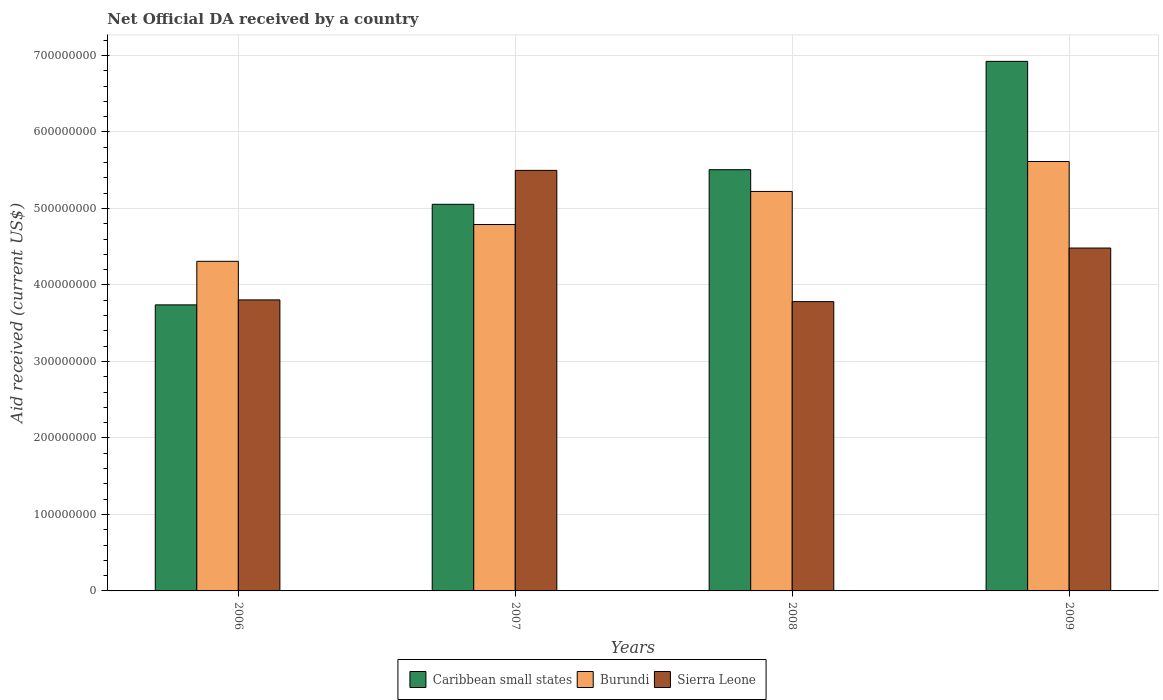Are the number of bars on each tick of the X-axis equal?
Your answer should be compact. Yes. How many bars are there on the 1st tick from the right?
Your answer should be very brief. 3. What is the label of the 3rd group of bars from the left?
Your response must be concise. 2008. In how many cases, is the number of bars for a given year not equal to the number of legend labels?
Provide a short and direct response. 0. What is the net official development assistance aid received in Burundi in 2008?
Ensure brevity in your answer.  5.22e+08. Across all years, what is the maximum net official development assistance aid received in Sierra Leone?
Keep it short and to the point. 5.50e+08. Across all years, what is the minimum net official development assistance aid received in Caribbean small states?
Your answer should be compact. 3.74e+08. In which year was the net official development assistance aid received in Sierra Leone maximum?
Your response must be concise. 2007. In which year was the net official development assistance aid received in Caribbean small states minimum?
Keep it short and to the point. 2006. What is the total net official development assistance aid received in Sierra Leone in the graph?
Provide a succinct answer. 1.76e+09. What is the difference between the net official development assistance aid received in Burundi in 2006 and that in 2008?
Ensure brevity in your answer.  -9.14e+07. What is the difference between the net official development assistance aid received in Sierra Leone in 2007 and the net official development assistance aid received in Caribbean small states in 2009?
Offer a very short reply. -1.43e+08. What is the average net official development assistance aid received in Caribbean small states per year?
Your answer should be compact. 5.31e+08. In the year 2006, what is the difference between the net official development assistance aid received in Burundi and net official development assistance aid received in Caribbean small states?
Your response must be concise. 5.69e+07. What is the ratio of the net official development assistance aid received in Caribbean small states in 2007 to that in 2009?
Offer a terse response. 0.73. Is the net official development assistance aid received in Sierra Leone in 2006 less than that in 2009?
Your response must be concise. Yes. Is the difference between the net official development assistance aid received in Burundi in 2006 and 2008 greater than the difference between the net official development assistance aid received in Caribbean small states in 2006 and 2008?
Your answer should be compact. Yes. What is the difference between the highest and the second highest net official development assistance aid received in Burundi?
Your answer should be very brief. 3.91e+07. What is the difference between the highest and the lowest net official development assistance aid received in Sierra Leone?
Give a very brief answer. 1.72e+08. What does the 3rd bar from the left in 2009 represents?
Make the answer very short. Sierra Leone. What does the 3rd bar from the right in 2007 represents?
Your response must be concise. Caribbean small states. Is it the case that in every year, the sum of the net official development assistance aid received in Burundi and net official development assistance aid received in Sierra Leone is greater than the net official development assistance aid received in Caribbean small states?
Give a very brief answer. Yes. What is the difference between two consecutive major ticks on the Y-axis?
Make the answer very short. 1.00e+08. Where does the legend appear in the graph?
Your answer should be very brief. Bottom center. How many legend labels are there?
Make the answer very short. 3. How are the legend labels stacked?
Your answer should be compact. Horizontal. What is the title of the graph?
Offer a very short reply. Net Official DA received by a country. Does "Fragile and conflict affected situations" appear as one of the legend labels in the graph?
Make the answer very short. No. What is the label or title of the Y-axis?
Your response must be concise. Aid received (current US$). What is the Aid received (current US$) in Caribbean small states in 2006?
Your answer should be compact. 3.74e+08. What is the Aid received (current US$) in Burundi in 2006?
Provide a succinct answer. 4.31e+08. What is the Aid received (current US$) of Sierra Leone in 2006?
Offer a very short reply. 3.80e+08. What is the Aid received (current US$) of Caribbean small states in 2007?
Your answer should be compact. 5.05e+08. What is the Aid received (current US$) of Burundi in 2007?
Your answer should be compact. 4.79e+08. What is the Aid received (current US$) of Sierra Leone in 2007?
Offer a terse response. 5.50e+08. What is the Aid received (current US$) in Caribbean small states in 2008?
Offer a terse response. 5.51e+08. What is the Aid received (current US$) of Burundi in 2008?
Provide a short and direct response. 5.22e+08. What is the Aid received (current US$) of Sierra Leone in 2008?
Keep it short and to the point. 3.78e+08. What is the Aid received (current US$) of Caribbean small states in 2009?
Give a very brief answer. 6.92e+08. What is the Aid received (current US$) in Burundi in 2009?
Provide a succinct answer. 5.61e+08. What is the Aid received (current US$) in Sierra Leone in 2009?
Your response must be concise. 4.48e+08. Across all years, what is the maximum Aid received (current US$) of Caribbean small states?
Provide a succinct answer. 6.92e+08. Across all years, what is the maximum Aid received (current US$) in Burundi?
Give a very brief answer. 5.61e+08. Across all years, what is the maximum Aid received (current US$) in Sierra Leone?
Ensure brevity in your answer.  5.50e+08. Across all years, what is the minimum Aid received (current US$) in Caribbean small states?
Keep it short and to the point. 3.74e+08. Across all years, what is the minimum Aid received (current US$) of Burundi?
Provide a succinct answer. 4.31e+08. Across all years, what is the minimum Aid received (current US$) in Sierra Leone?
Your answer should be very brief. 3.78e+08. What is the total Aid received (current US$) in Caribbean small states in the graph?
Your response must be concise. 2.12e+09. What is the total Aid received (current US$) of Burundi in the graph?
Provide a short and direct response. 1.99e+09. What is the total Aid received (current US$) in Sierra Leone in the graph?
Your answer should be very brief. 1.76e+09. What is the difference between the Aid received (current US$) in Caribbean small states in 2006 and that in 2007?
Provide a succinct answer. -1.31e+08. What is the difference between the Aid received (current US$) of Burundi in 2006 and that in 2007?
Make the answer very short. -4.81e+07. What is the difference between the Aid received (current US$) of Sierra Leone in 2006 and that in 2007?
Offer a very short reply. -1.69e+08. What is the difference between the Aid received (current US$) in Caribbean small states in 2006 and that in 2008?
Your answer should be very brief. -1.77e+08. What is the difference between the Aid received (current US$) of Burundi in 2006 and that in 2008?
Offer a terse response. -9.14e+07. What is the difference between the Aid received (current US$) of Sierra Leone in 2006 and that in 2008?
Keep it short and to the point. 2.26e+06. What is the difference between the Aid received (current US$) of Caribbean small states in 2006 and that in 2009?
Keep it short and to the point. -3.18e+08. What is the difference between the Aid received (current US$) of Burundi in 2006 and that in 2009?
Your answer should be very brief. -1.30e+08. What is the difference between the Aid received (current US$) in Sierra Leone in 2006 and that in 2009?
Offer a terse response. -6.78e+07. What is the difference between the Aid received (current US$) of Caribbean small states in 2007 and that in 2008?
Provide a short and direct response. -4.52e+07. What is the difference between the Aid received (current US$) in Burundi in 2007 and that in 2008?
Your response must be concise. -4.32e+07. What is the difference between the Aid received (current US$) of Sierra Leone in 2007 and that in 2008?
Offer a terse response. 1.72e+08. What is the difference between the Aid received (current US$) in Caribbean small states in 2007 and that in 2009?
Ensure brevity in your answer.  -1.87e+08. What is the difference between the Aid received (current US$) in Burundi in 2007 and that in 2009?
Offer a very short reply. -8.24e+07. What is the difference between the Aid received (current US$) of Sierra Leone in 2007 and that in 2009?
Offer a terse response. 1.02e+08. What is the difference between the Aid received (current US$) in Caribbean small states in 2008 and that in 2009?
Give a very brief answer. -1.42e+08. What is the difference between the Aid received (current US$) of Burundi in 2008 and that in 2009?
Offer a very short reply. -3.91e+07. What is the difference between the Aid received (current US$) in Sierra Leone in 2008 and that in 2009?
Provide a succinct answer. -7.00e+07. What is the difference between the Aid received (current US$) of Caribbean small states in 2006 and the Aid received (current US$) of Burundi in 2007?
Provide a succinct answer. -1.05e+08. What is the difference between the Aid received (current US$) in Caribbean small states in 2006 and the Aid received (current US$) in Sierra Leone in 2007?
Provide a succinct answer. -1.76e+08. What is the difference between the Aid received (current US$) of Burundi in 2006 and the Aid received (current US$) of Sierra Leone in 2007?
Provide a succinct answer. -1.19e+08. What is the difference between the Aid received (current US$) of Caribbean small states in 2006 and the Aid received (current US$) of Burundi in 2008?
Provide a succinct answer. -1.48e+08. What is the difference between the Aid received (current US$) in Caribbean small states in 2006 and the Aid received (current US$) in Sierra Leone in 2008?
Make the answer very short. -4.24e+06. What is the difference between the Aid received (current US$) of Burundi in 2006 and the Aid received (current US$) of Sierra Leone in 2008?
Keep it short and to the point. 5.27e+07. What is the difference between the Aid received (current US$) in Caribbean small states in 2006 and the Aid received (current US$) in Burundi in 2009?
Provide a succinct answer. -1.87e+08. What is the difference between the Aid received (current US$) in Caribbean small states in 2006 and the Aid received (current US$) in Sierra Leone in 2009?
Give a very brief answer. -7.43e+07. What is the difference between the Aid received (current US$) of Burundi in 2006 and the Aid received (current US$) of Sierra Leone in 2009?
Keep it short and to the point. -1.74e+07. What is the difference between the Aid received (current US$) of Caribbean small states in 2007 and the Aid received (current US$) of Burundi in 2008?
Provide a succinct answer. -1.68e+07. What is the difference between the Aid received (current US$) of Caribbean small states in 2007 and the Aid received (current US$) of Sierra Leone in 2008?
Ensure brevity in your answer.  1.27e+08. What is the difference between the Aid received (current US$) in Burundi in 2007 and the Aid received (current US$) in Sierra Leone in 2008?
Your answer should be compact. 1.01e+08. What is the difference between the Aid received (current US$) in Caribbean small states in 2007 and the Aid received (current US$) in Burundi in 2009?
Keep it short and to the point. -5.59e+07. What is the difference between the Aid received (current US$) in Caribbean small states in 2007 and the Aid received (current US$) in Sierra Leone in 2009?
Ensure brevity in your answer.  5.72e+07. What is the difference between the Aid received (current US$) in Burundi in 2007 and the Aid received (current US$) in Sierra Leone in 2009?
Make the answer very short. 3.07e+07. What is the difference between the Aid received (current US$) of Caribbean small states in 2008 and the Aid received (current US$) of Burundi in 2009?
Make the answer very short. -1.07e+07. What is the difference between the Aid received (current US$) in Caribbean small states in 2008 and the Aid received (current US$) in Sierra Leone in 2009?
Make the answer very short. 1.02e+08. What is the difference between the Aid received (current US$) of Burundi in 2008 and the Aid received (current US$) of Sierra Leone in 2009?
Your answer should be compact. 7.40e+07. What is the average Aid received (current US$) of Caribbean small states per year?
Your answer should be very brief. 5.31e+08. What is the average Aid received (current US$) of Burundi per year?
Provide a short and direct response. 4.98e+08. What is the average Aid received (current US$) in Sierra Leone per year?
Your answer should be very brief. 4.39e+08. In the year 2006, what is the difference between the Aid received (current US$) of Caribbean small states and Aid received (current US$) of Burundi?
Ensure brevity in your answer.  -5.69e+07. In the year 2006, what is the difference between the Aid received (current US$) of Caribbean small states and Aid received (current US$) of Sierra Leone?
Give a very brief answer. -6.50e+06. In the year 2006, what is the difference between the Aid received (current US$) in Burundi and Aid received (current US$) in Sierra Leone?
Your response must be concise. 5.04e+07. In the year 2007, what is the difference between the Aid received (current US$) of Caribbean small states and Aid received (current US$) of Burundi?
Offer a very short reply. 2.64e+07. In the year 2007, what is the difference between the Aid received (current US$) in Caribbean small states and Aid received (current US$) in Sierra Leone?
Provide a short and direct response. -4.43e+07. In the year 2007, what is the difference between the Aid received (current US$) in Burundi and Aid received (current US$) in Sierra Leone?
Offer a terse response. -7.08e+07. In the year 2008, what is the difference between the Aid received (current US$) of Caribbean small states and Aid received (current US$) of Burundi?
Your response must be concise. 2.84e+07. In the year 2008, what is the difference between the Aid received (current US$) in Caribbean small states and Aid received (current US$) in Sierra Leone?
Your answer should be very brief. 1.72e+08. In the year 2008, what is the difference between the Aid received (current US$) in Burundi and Aid received (current US$) in Sierra Leone?
Ensure brevity in your answer.  1.44e+08. In the year 2009, what is the difference between the Aid received (current US$) in Caribbean small states and Aid received (current US$) in Burundi?
Give a very brief answer. 1.31e+08. In the year 2009, what is the difference between the Aid received (current US$) in Caribbean small states and Aid received (current US$) in Sierra Leone?
Provide a short and direct response. 2.44e+08. In the year 2009, what is the difference between the Aid received (current US$) in Burundi and Aid received (current US$) in Sierra Leone?
Make the answer very short. 1.13e+08. What is the ratio of the Aid received (current US$) of Caribbean small states in 2006 to that in 2007?
Your answer should be compact. 0.74. What is the ratio of the Aid received (current US$) of Burundi in 2006 to that in 2007?
Ensure brevity in your answer.  0.9. What is the ratio of the Aid received (current US$) of Sierra Leone in 2006 to that in 2007?
Keep it short and to the point. 0.69. What is the ratio of the Aid received (current US$) of Caribbean small states in 2006 to that in 2008?
Your answer should be compact. 0.68. What is the ratio of the Aid received (current US$) in Burundi in 2006 to that in 2008?
Provide a succinct answer. 0.83. What is the ratio of the Aid received (current US$) of Caribbean small states in 2006 to that in 2009?
Offer a very short reply. 0.54. What is the ratio of the Aid received (current US$) of Burundi in 2006 to that in 2009?
Make the answer very short. 0.77. What is the ratio of the Aid received (current US$) of Sierra Leone in 2006 to that in 2009?
Offer a very short reply. 0.85. What is the ratio of the Aid received (current US$) of Caribbean small states in 2007 to that in 2008?
Your answer should be very brief. 0.92. What is the ratio of the Aid received (current US$) of Burundi in 2007 to that in 2008?
Give a very brief answer. 0.92. What is the ratio of the Aid received (current US$) in Sierra Leone in 2007 to that in 2008?
Give a very brief answer. 1.45. What is the ratio of the Aid received (current US$) in Caribbean small states in 2007 to that in 2009?
Offer a terse response. 0.73. What is the ratio of the Aid received (current US$) of Burundi in 2007 to that in 2009?
Provide a short and direct response. 0.85. What is the ratio of the Aid received (current US$) of Sierra Leone in 2007 to that in 2009?
Provide a short and direct response. 1.23. What is the ratio of the Aid received (current US$) of Caribbean small states in 2008 to that in 2009?
Your answer should be very brief. 0.8. What is the ratio of the Aid received (current US$) of Burundi in 2008 to that in 2009?
Ensure brevity in your answer.  0.93. What is the ratio of the Aid received (current US$) of Sierra Leone in 2008 to that in 2009?
Your response must be concise. 0.84. What is the difference between the highest and the second highest Aid received (current US$) of Caribbean small states?
Offer a very short reply. 1.42e+08. What is the difference between the highest and the second highest Aid received (current US$) of Burundi?
Your response must be concise. 3.91e+07. What is the difference between the highest and the second highest Aid received (current US$) of Sierra Leone?
Provide a succinct answer. 1.02e+08. What is the difference between the highest and the lowest Aid received (current US$) in Caribbean small states?
Keep it short and to the point. 3.18e+08. What is the difference between the highest and the lowest Aid received (current US$) in Burundi?
Keep it short and to the point. 1.30e+08. What is the difference between the highest and the lowest Aid received (current US$) in Sierra Leone?
Offer a very short reply. 1.72e+08. 